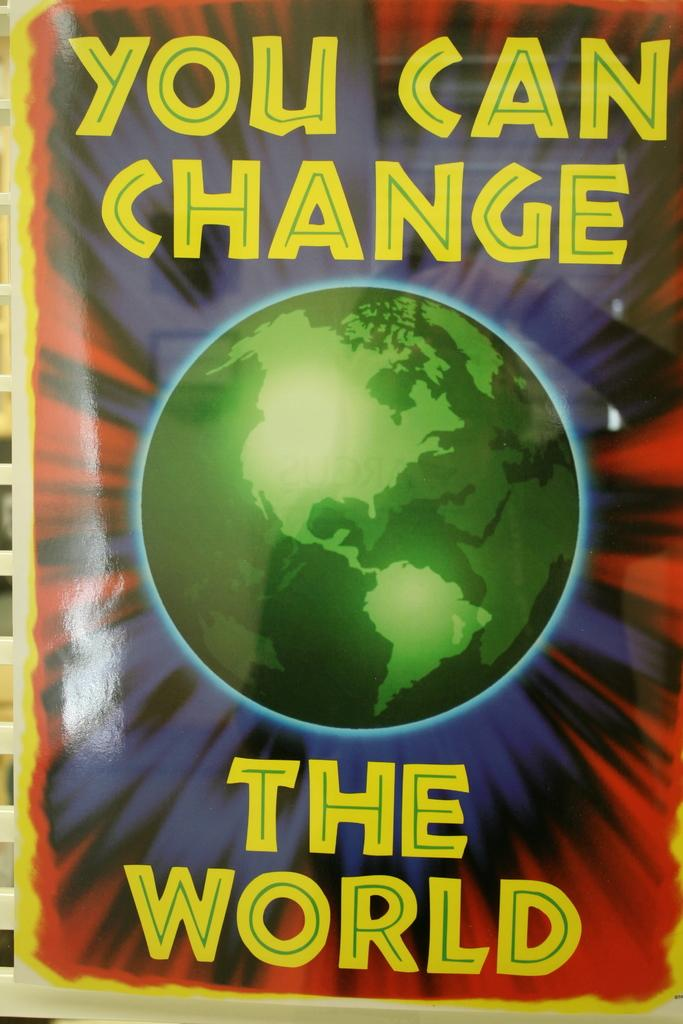<image>
Create a compact narrative representing the image presented. The book cover of You Can Change the World has an image of the Earth in the center. 